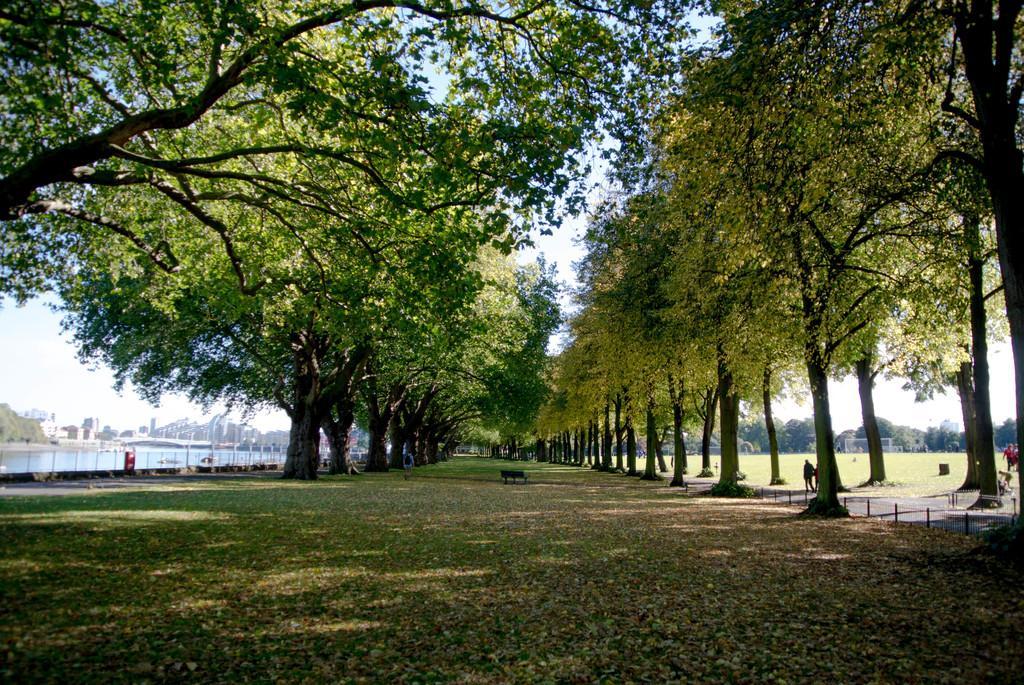Can you describe this image briefly? In this image we can see the grass, bench, people walking on the road, trees, water, buildings and the sky in the background. 